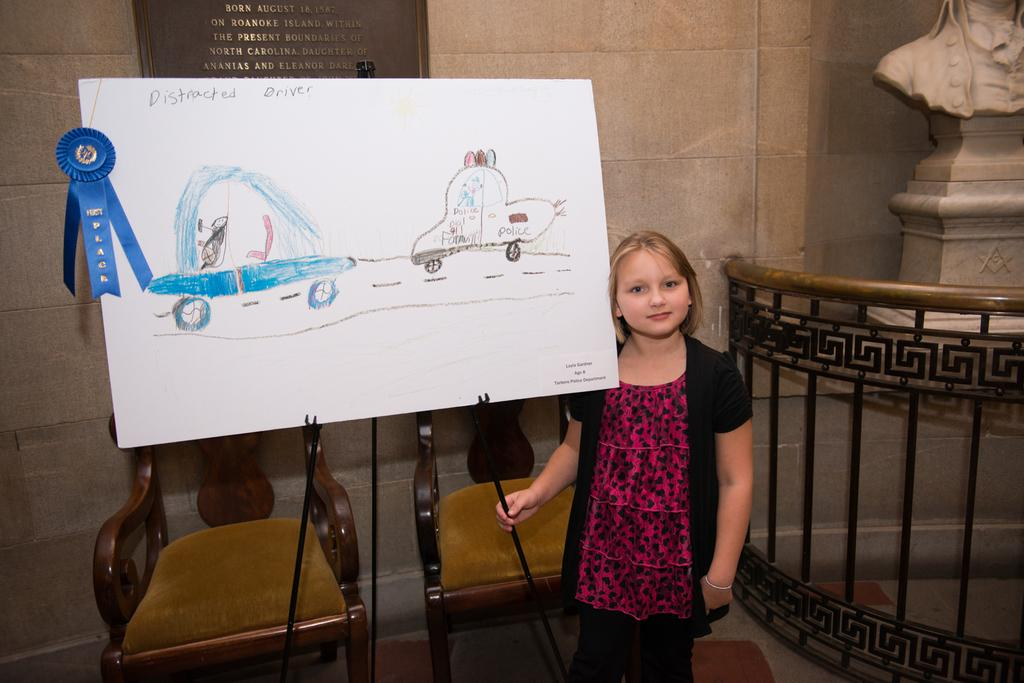Who is the main subject in the image? There is a little girl in the image. What is the girl standing near? The girl is standing near a note stand. What can be seen on the note stand? There is a blue color ribbon on the note stand. What is behind the note stand? There are two chairs behind the note stand. What type of country is the little girl visiting in the image? There is no indication of the little girl visiting a country in the image. 